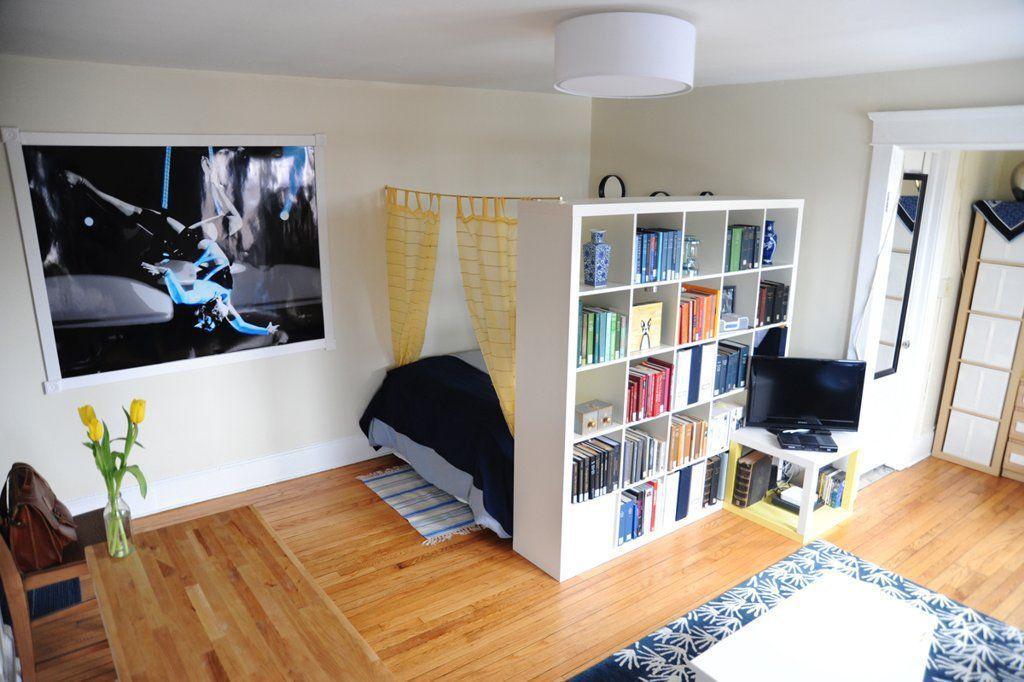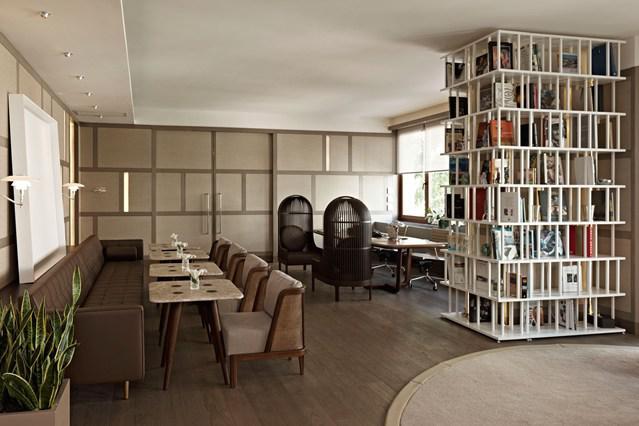The first image is the image on the left, the second image is the image on the right. Examine the images to the left and right. Is the description "In one image a large room-dividing shelf unit is placed near the foot of a bed." accurate? Answer yes or no. Yes. The first image is the image on the left, the second image is the image on the right. For the images displayed, is the sentence "One room has an opened doorway through the middle of a wall of white bookshelves." factually correct? Answer yes or no. No. The first image is the image on the left, the second image is the image on the right. For the images displayed, is the sentence "A white bookcase separates a bed from the rest of the living space." factually correct? Answer yes or no. Yes. The first image is the image on the left, the second image is the image on the right. Evaluate the accuracy of this statement regarding the images: "In one image, a white shelving unit surrounds a central door that is standing open, with floor-to-ceiling shelves on both sides and over the door.". Is it true? Answer yes or no. No. 